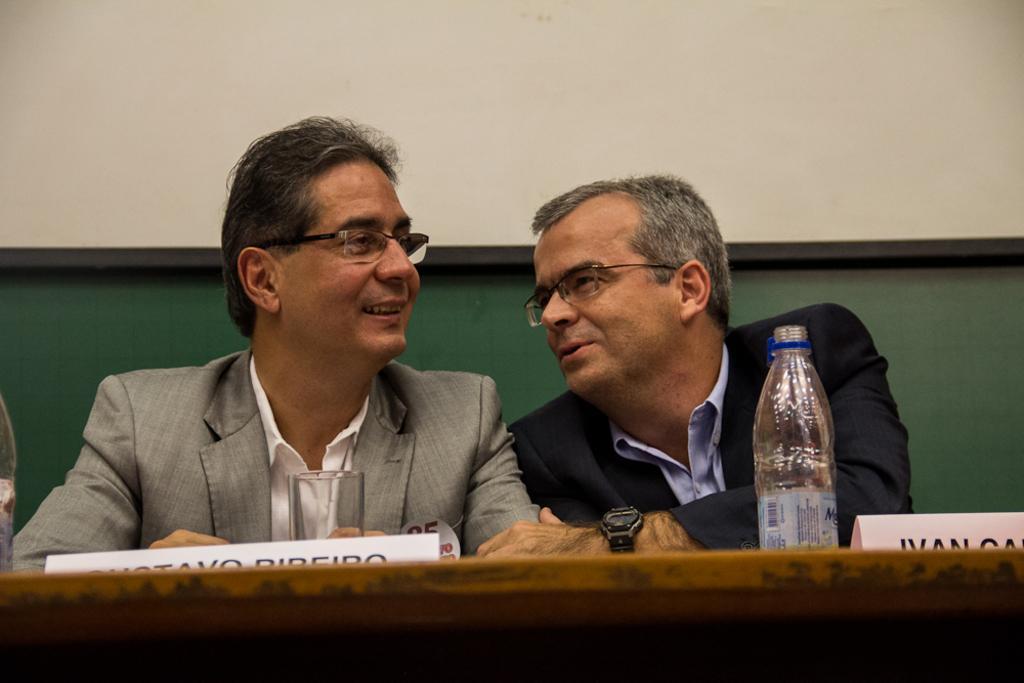Describe this image in one or two sentences. The two persons are sitting on chairs. They are smiling. There is a table. There is a bottle,glass,name board on a glass. We can see in the background wall,board. 